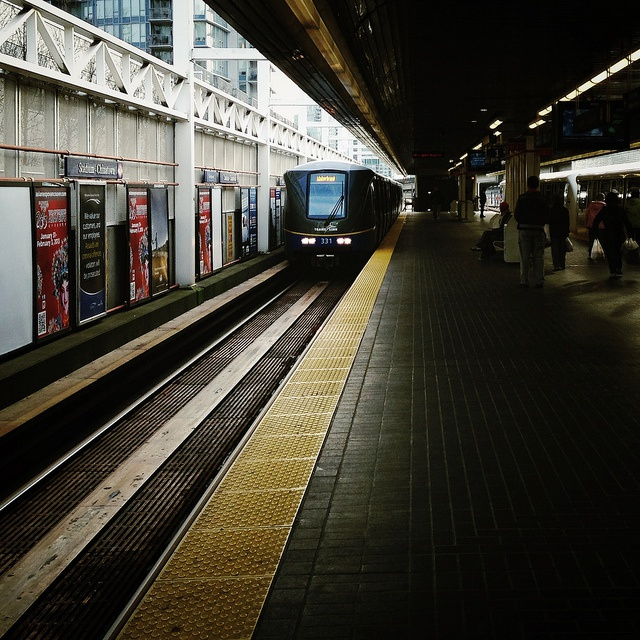Describe the objects in this image and their specific colors. I can see train in gray, black, lightgray, and blue tones, tv in black, blue, darkblue, and gray tones, people in gray, black, and darkgreen tones, people in gray, black, darkgreen, and darkgray tones, and people in black and gray tones in this image. 